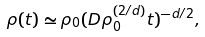<formula> <loc_0><loc_0><loc_500><loc_500>\rho ( t ) \simeq \rho _ { 0 } ( D \rho _ { 0 } ^ { ( 2 / d ) } t ) ^ { - d / 2 } ,</formula> 